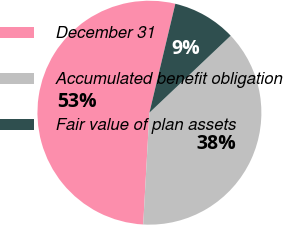<chart> <loc_0><loc_0><loc_500><loc_500><pie_chart><fcel>December 31<fcel>Accumulated benefit obligation<fcel>Fair value of plan assets<nl><fcel>52.83%<fcel>37.95%<fcel>9.21%<nl></chart> 